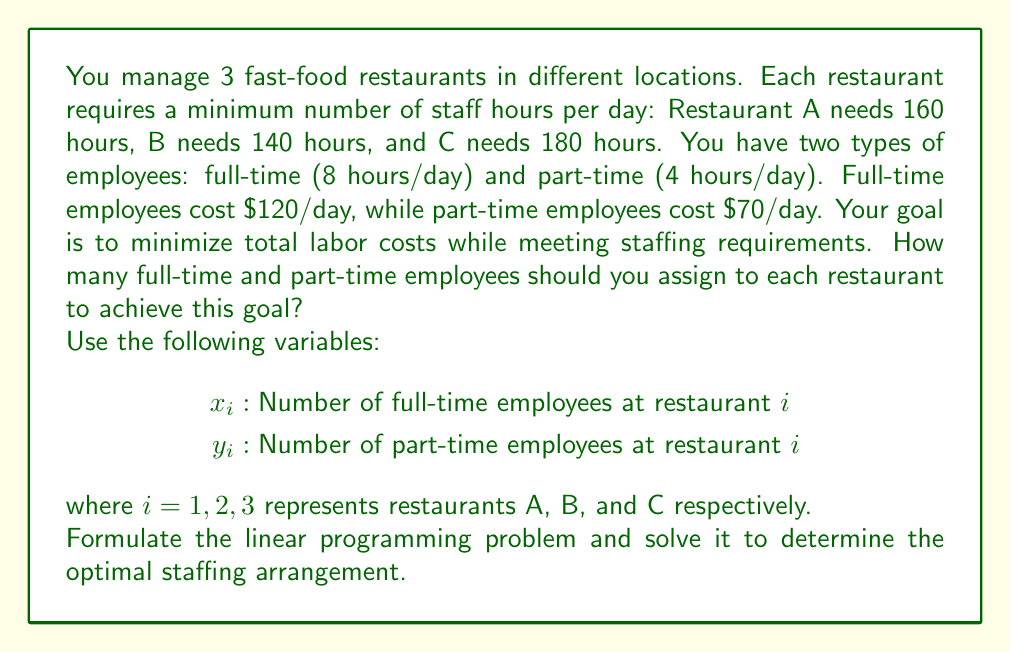What is the answer to this math problem? To solve this problem, we need to formulate and solve a linear programming model:

1. Objective function (minimize total cost):
   $$\text{Minimize } Z = 120(x_1 + x_2 + x_3) + 70(y_1 + y_2 + y_3)$$

2. Constraints (staffing requirements):
   Restaurant A: $8x_1 + 4y_1 \geq 160$
   Restaurant B: $8x_2 + 4y_2 \geq 140$
   Restaurant C: $8x_3 + 4y_3 \geq 180$

3. Non-negativity constraints:
   $x_i \geq 0$ and $y_i \geq 0$ for i = 1, 2, 3

4. Integer constraints:
   $x_i$ and $y_i$ must be integers for i = 1, 2, 3

To solve this integer linear programming problem, we can use software like LINGO or Excel Solver. The optimal solution is:

Restaurant A: $x_1 = 20$, $y_1 = 0$
Restaurant B: $x_2 = 17$, $y_2 = 2$
Restaurant C: $x_3 = 22$, $y_3 = 2$

5. Verify the solution:
   Restaurant A: $8(20) + 4(0) = 160$ hours (meets requirement)
   Restaurant B: $8(17) + 4(2) = 144$ hours (meets requirement)
   Restaurant C: $8(22) + 4(2) = 184$ hours (meets requirement)

6. Calculate total cost:
   $Z = 120(20 + 17 + 22) + 70(0 + 2 + 2) = 7,240$

This staffing arrangement minimizes the total labor cost while meeting all staffing requirements.
Answer: Restaurant A: 20 full-time, 0 part-time
Restaurant B: 17 full-time, 2 part-time
Restaurant C: 22 full-time, 2 part-time
Total cost: $7,240/day 